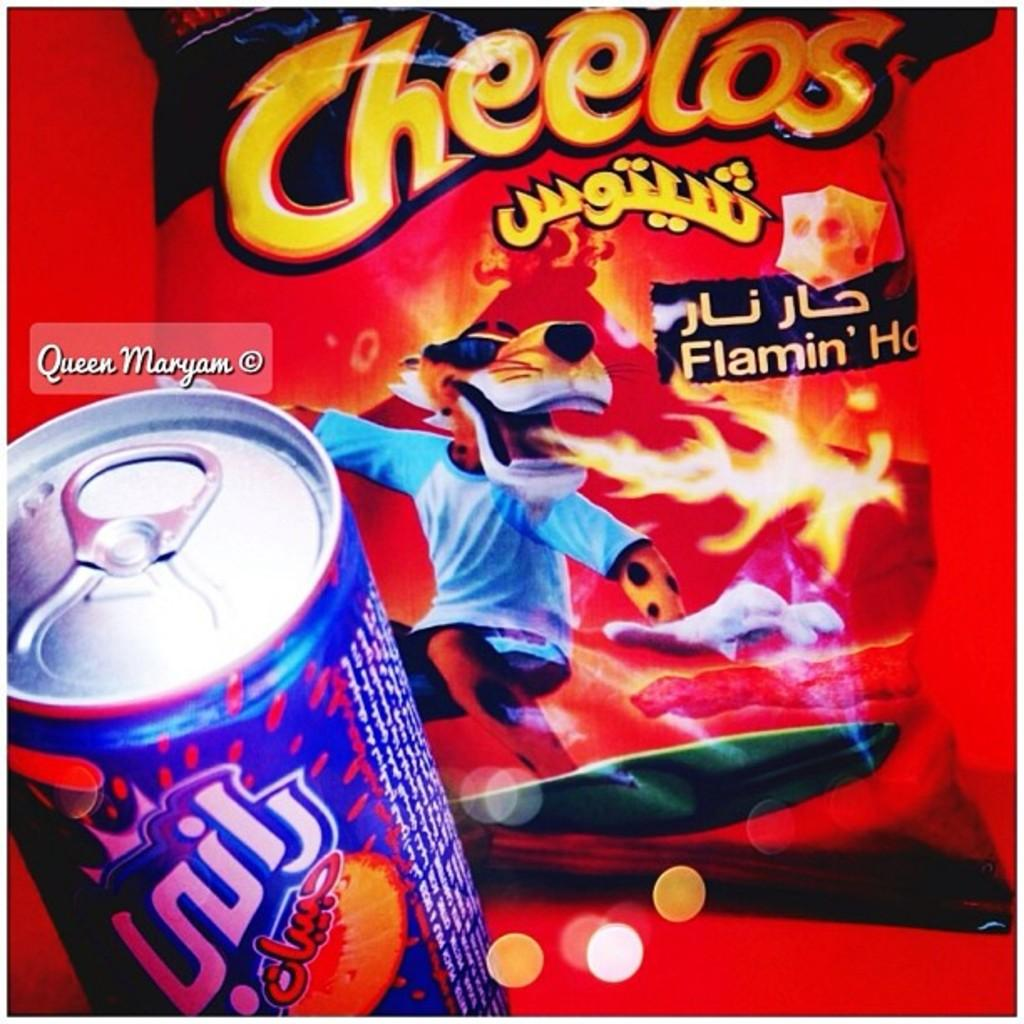<image>
Provide a brief description of the given image. A Cheetos bag shows Chester cheetah with flames coming out of his mouth. 